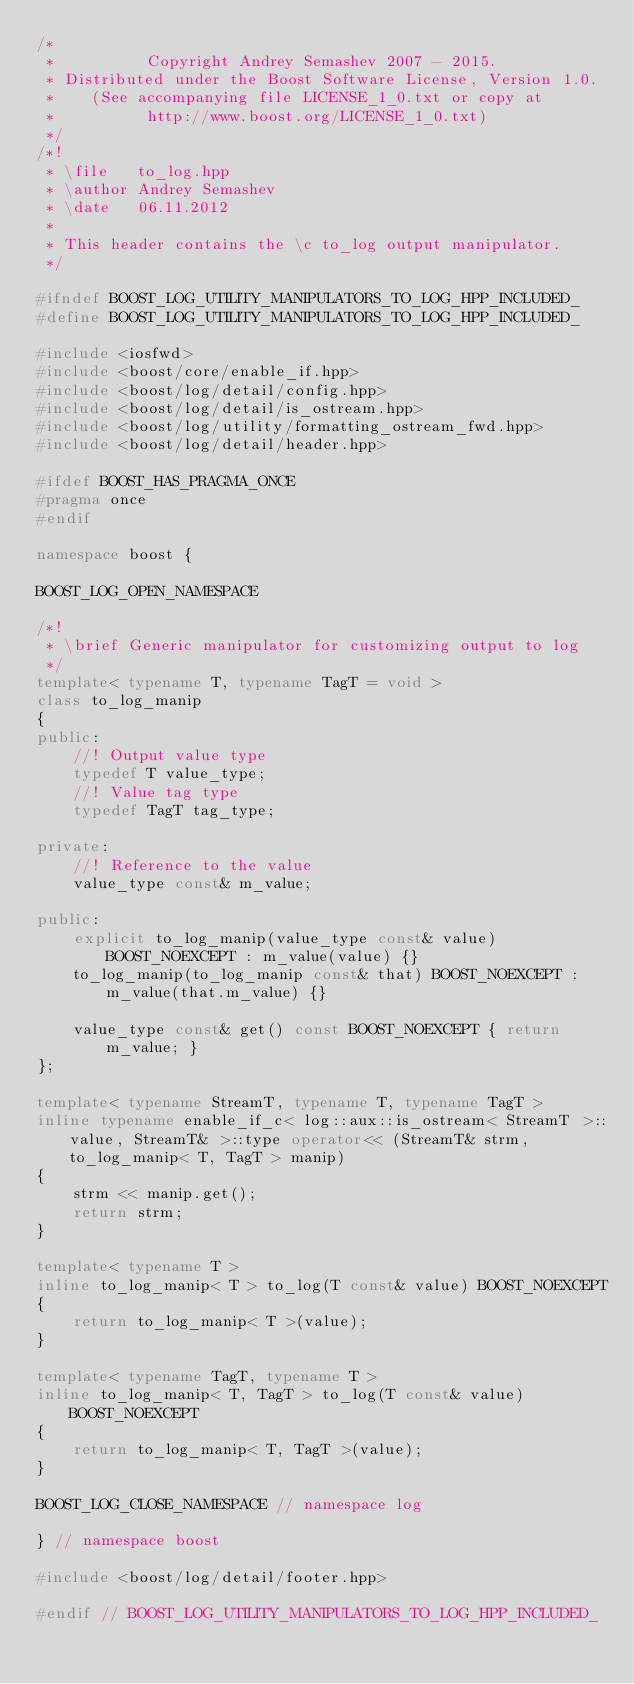Convert code to text. <code><loc_0><loc_0><loc_500><loc_500><_C++_>/*
 *          Copyright Andrey Semashev 2007 - 2015.
 * Distributed under the Boost Software License, Version 1.0.
 *    (See accompanying file LICENSE_1_0.txt or copy at
 *          http://www.boost.org/LICENSE_1_0.txt)
 */
/*!
 * \file   to_log.hpp
 * \author Andrey Semashev
 * \date   06.11.2012
 *
 * This header contains the \c to_log output manipulator.
 */

#ifndef BOOST_LOG_UTILITY_MANIPULATORS_TO_LOG_HPP_INCLUDED_
#define BOOST_LOG_UTILITY_MANIPULATORS_TO_LOG_HPP_INCLUDED_

#include <iosfwd>
#include <boost/core/enable_if.hpp>
#include <boost/log/detail/config.hpp>
#include <boost/log/detail/is_ostream.hpp>
#include <boost/log/utility/formatting_ostream_fwd.hpp>
#include <boost/log/detail/header.hpp>

#ifdef BOOST_HAS_PRAGMA_ONCE
#pragma once
#endif

namespace boost {

BOOST_LOG_OPEN_NAMESPACE

/*!
 * \brief Generic manipulator for customizing output to log
 */
template< typename T, typename TagT = void >
class to_log_manip
{
public:
    //! Output value type
    typedef T value_type;
    //! Value tag type
    typedef TagT tag_type;

private:
    //! Reference to the value
    value_type const& m_value;

public:
    explicit to_log_manip(value_type const& value) BOOST_NOEXCEPT : m_value(value) {}
    to_log_manip(to_log_manip const& that) BOOST_NOEXCEPT : m_value(that.m_value) {}

    value_type const& get() const BOOST_NOEXCEPT { return m_value; }
};

template< typename StreamT, typename T, typename TagT >
inline typename enable_if_c< log::aux::is_ostream< StreamT >::value, StreamT& >::type operator<< (StreamT& strm, to_log_manip< T, TagT > manip)
{
    strm << manip.get();
    return strm;
}

template< typename T >
inline to_log_manip< T > to_log(T const& value) BOOST_NOEXCEPT
{
    return to_log_manip< T >(value);
}

template< typename TagT, typename T >
inline to_log_manip< T, TagT > to_log(T const& value) BOOST_NOEXCEPT
{
    return to_log_manip< T, TagT >(value);
}

BOOST_LOG_CLOSE_NAMESPACE // namespace log

} // namespace boost

#include <boost/log/detail/footer.hpp>

#endif // BOOST_LOG_UTILITY_MANIPULATORS_TO_LOG_HPP_INCLUDED_
</code> 